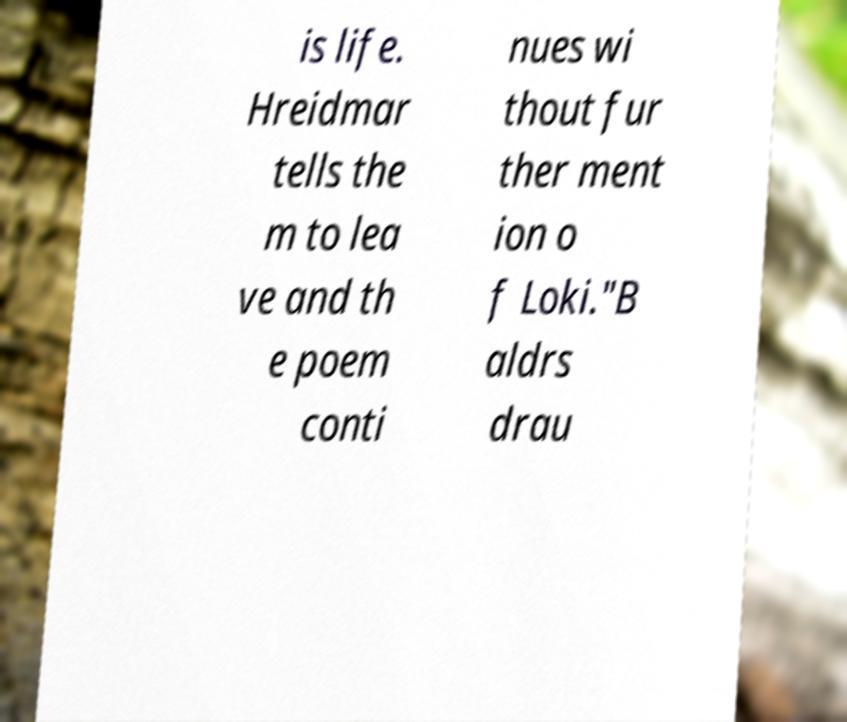Can you read and provide the text displayed in the image?This photo seems to have some interesting text. Can you extract and type it out for me? is life. Hreidmar tells the m to lea ve and th e poem conti nues wi thout fur ther ment ion o f Loki."B aldrs drau 